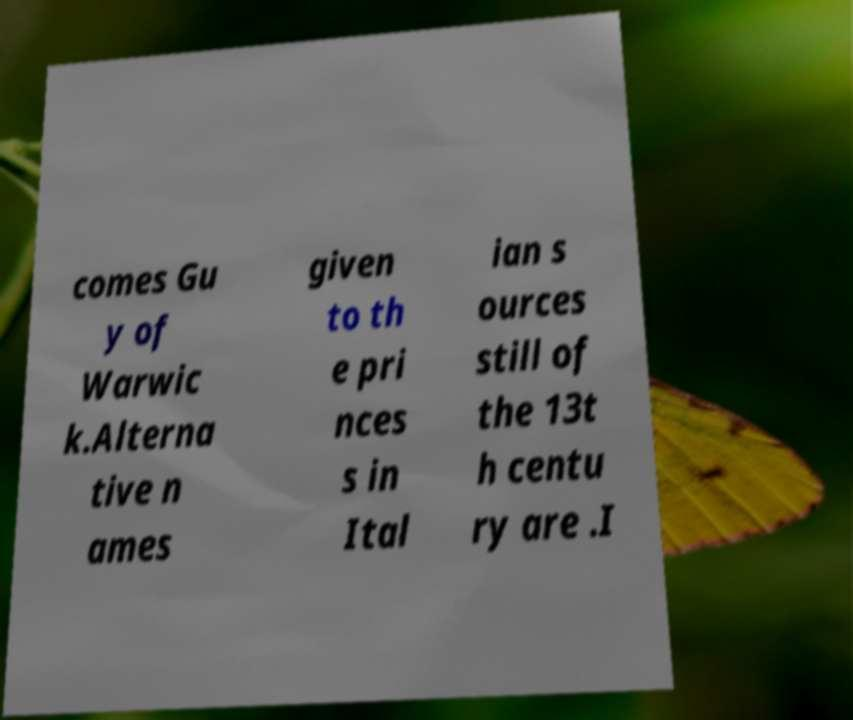I need the written content from this picture converted into text. Can you do that? comes Gu y of Warwic k.Alterna tive n ames given to th e pri nces s in Ital ian s ources still of the 13t h centu ry are .I 